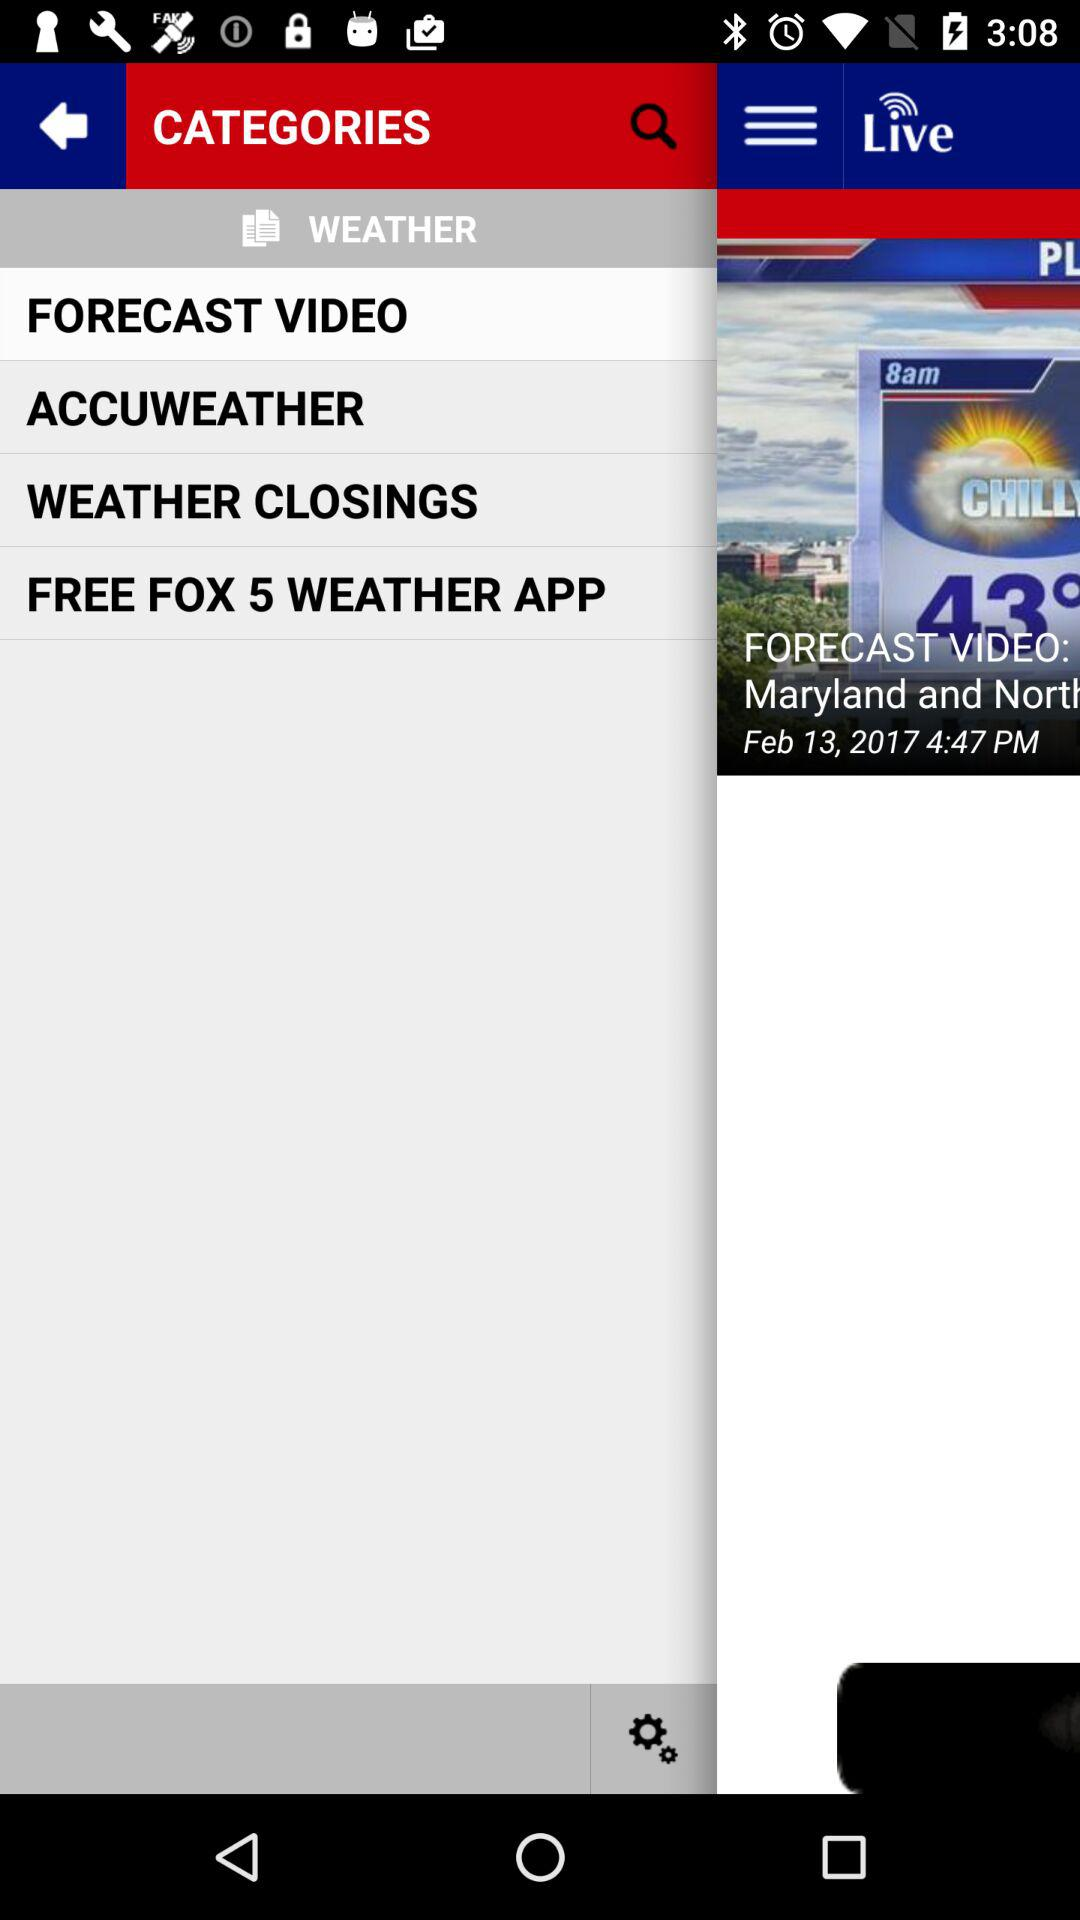Which tab is currently selected? The currently selected tab is "FORECAST VIDEO". 